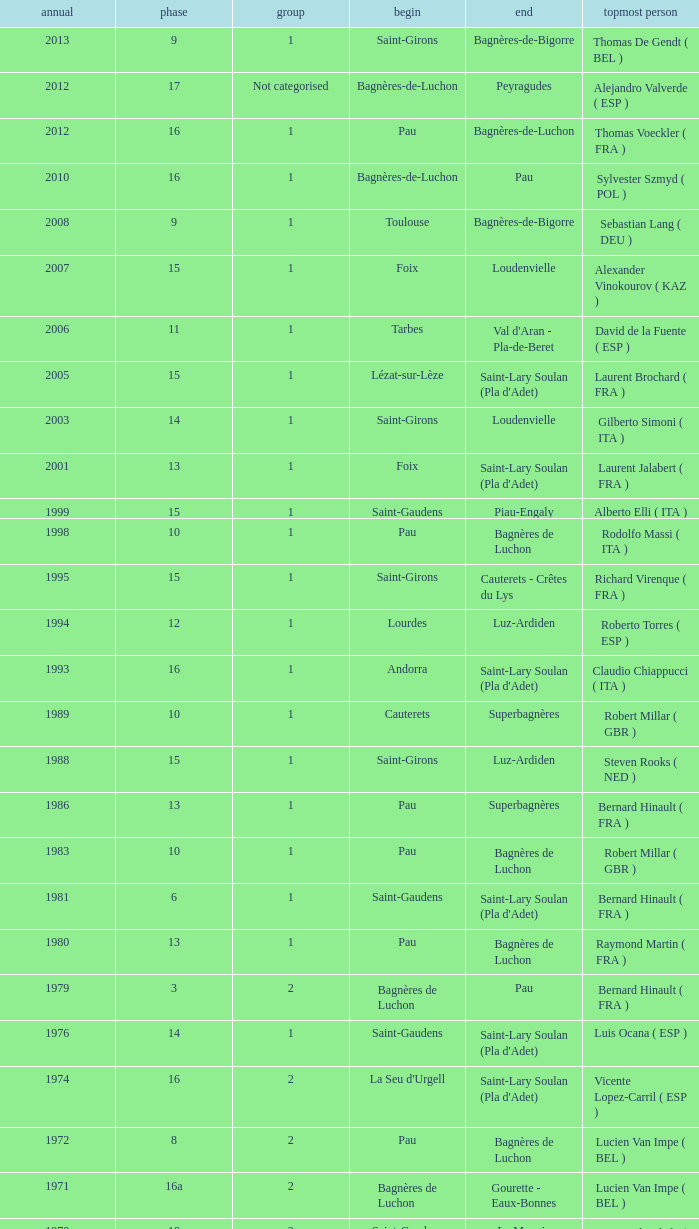What category was in 1964? 2.0. 